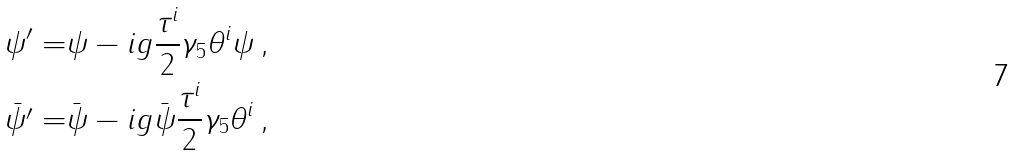<formula> <loc_0><loc_0><loc_500><loc_500>\psi ^ { \prime } = & \psi - i g \frac { \tau ^ { i } } { 2 } \gamma _ { 5 } \theta ^ { i } \psi \, , \\ \bar { \psi ^ { \prime } } = & \bar { \psi } - i g \bar { \psi } \frac { \tau ^ { i } } { 2 } \gamma _ { 5 } \theta ^ { i } \, ,</formula> 